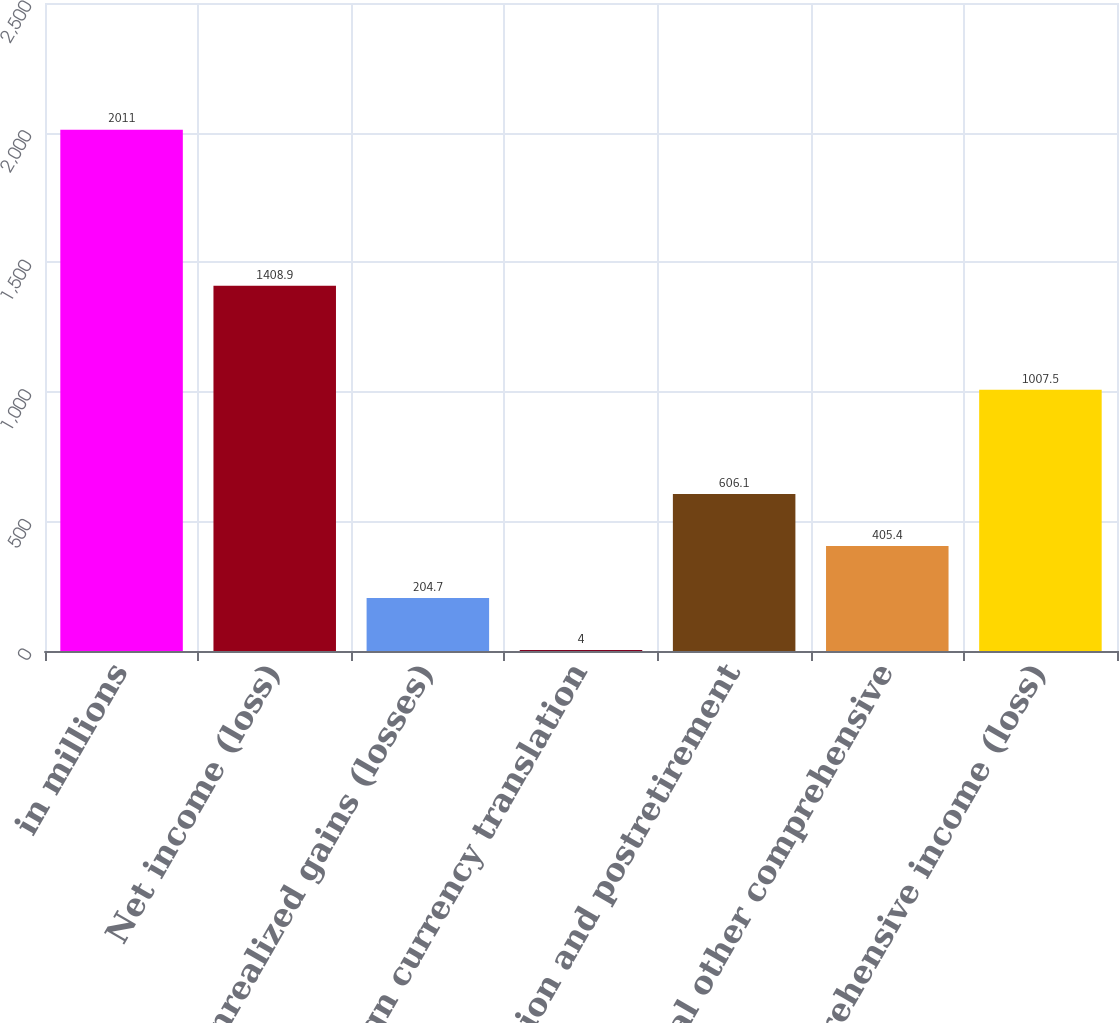Convert chart. <chart><loc_0><loc_0><loc_500><loc_500><bar_chart><fcel>in millions<fcel>Net income (loss)<fcel>Net unrealized gains (losses)<fcel>Foreign currency translation<fcel>Net pension and postretirement<fcel>Total other comprehensive<fcel>Comprehensive income (loss)<nl><fcel>2011<fcel>1408.9<fcel>204.7<fcel>4<fcel>606.1<fcel>405.4<fcel>1007.5<nl></chart> 